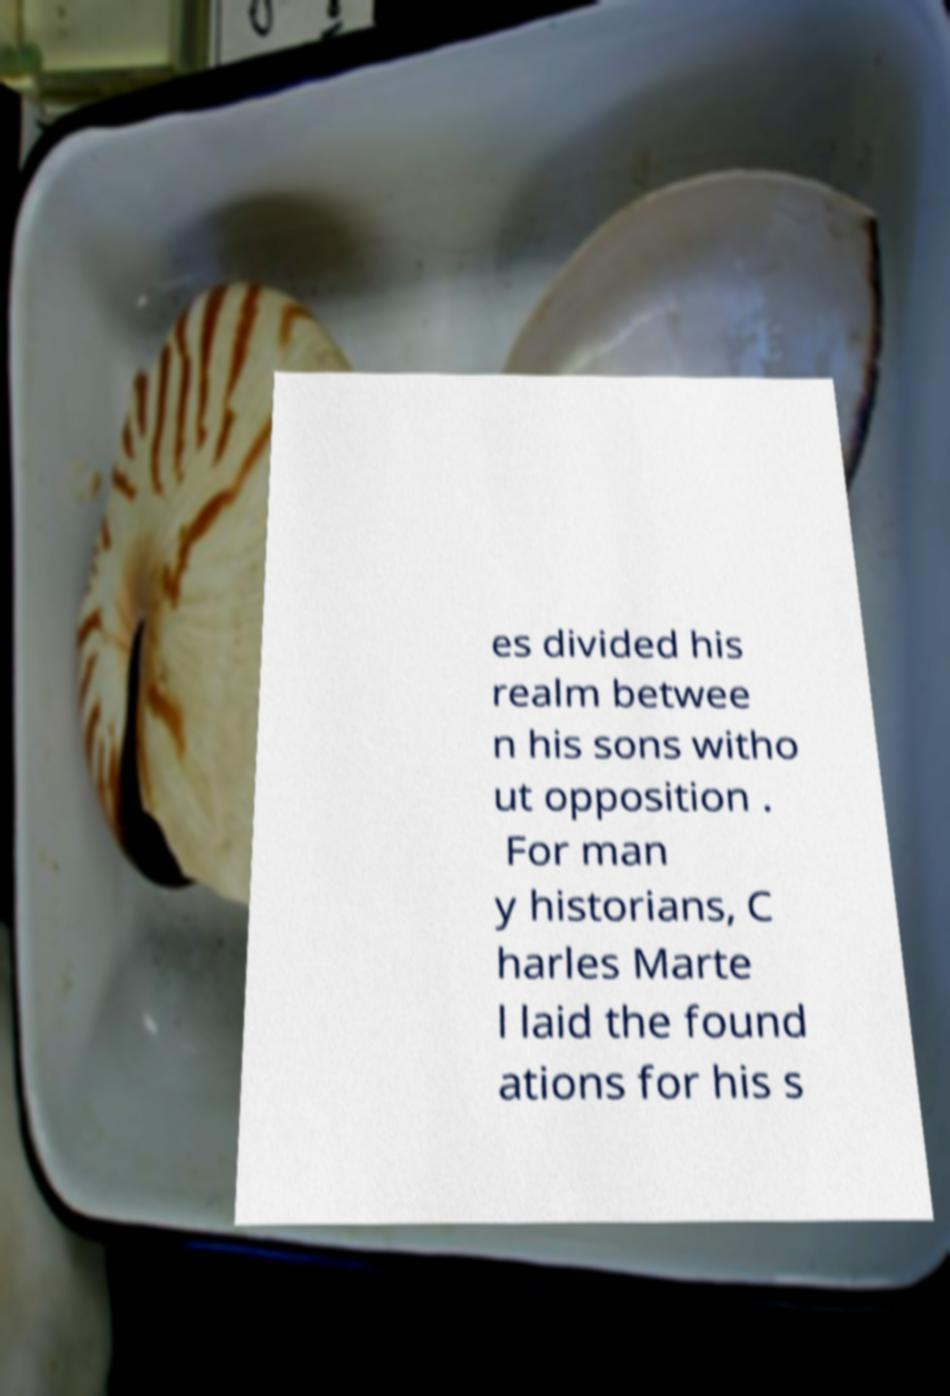For documentation purposes, I need the text within this image transcribed. Could you provide that? es divided his realm betwee n his sons witho ut opposition . For man y historians, C harles Marte l laid the found ations for his s 